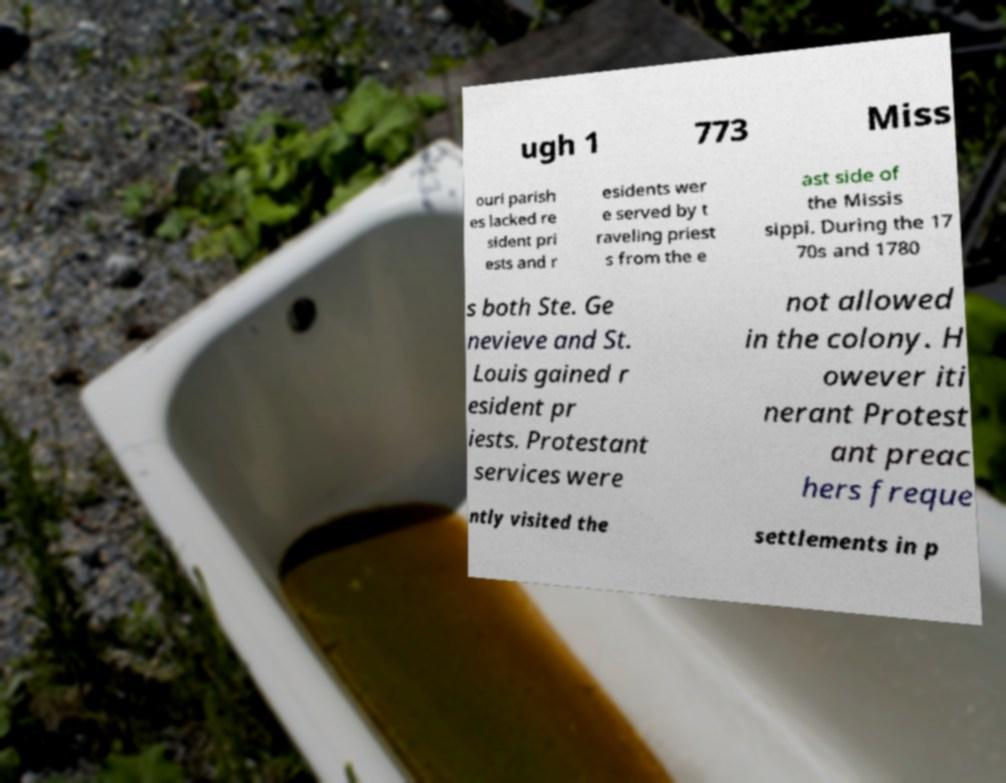I need the written content from this picture converted into text. Can you do that? ugh 1 773 Miss ouri parish es lacked re sident pri ests and r esidents wer e served by t raveling priest s from the e ast side of the Missis sippi. During the 17 70s and 1780 s both Ste. Ge nevieve and St. Louis gained r esident pr iests. Protestant services were not allowed in the colony. H owever iti nerant Protest ant preac hers freque ntly visited the settlements in p 